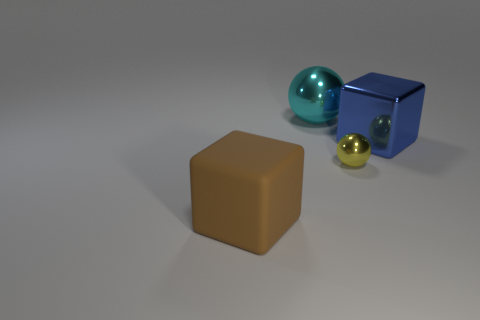Subtract all yellow spheres. How many spheres are left? 1 Add 1 big green metal blocks. How many objects exist? 5 Subtract 2 blocks. How many blocks are left? 0 Subtract all large purple shiny blocks. Subtract all large matte objects. How many objects are left? 3 Add 3 large blue things. How many large blue things are left? 4 Add 1 small green shiny cylinders. How many small green shiny cylinders exist? 1 Subtract 0 brown cylinders. How many objects are left? 4 Subtract all green spheres. Subtract all cyan cylinders. How many spheres are left? 2 Subtract all blue cylinders. How many red balls are left? 0 